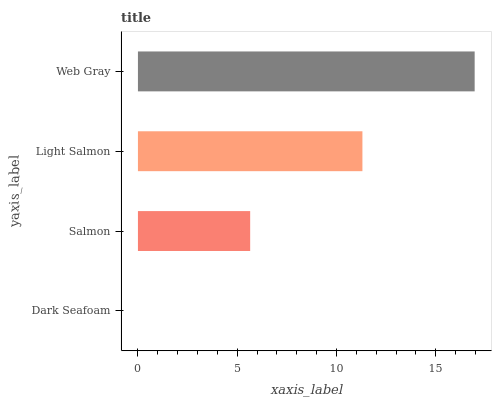Is Dark Seafoam the minimum?
Answer yes or no. Yes. Is Web Gray the maximum?
Answer yes or no. Yes. Is Salmon the minimum?
Answer yes or no. No. Is Salmon the maximum?
Answer yes or no. No. Is Salmon greater than Dark Seafoam?
Answer yes or no. Yes. Is Dark Seafoam less than Salmon?
Answer yes or no. Yes. Is Dark Seafoam greater than Salmon?
Answer yes or no. No. Is Salmon less than Dark Seafoam?
Answer yes or no. No. Is Light Salmon the high median?
Answer yes or no. Yes. Is Salmon the low median?
Answer yes or no. Yes. Is Dark Seafoam the high median?
Answer yes or no. No. Is Web Gray the low median?
Answer yes or no. No. 